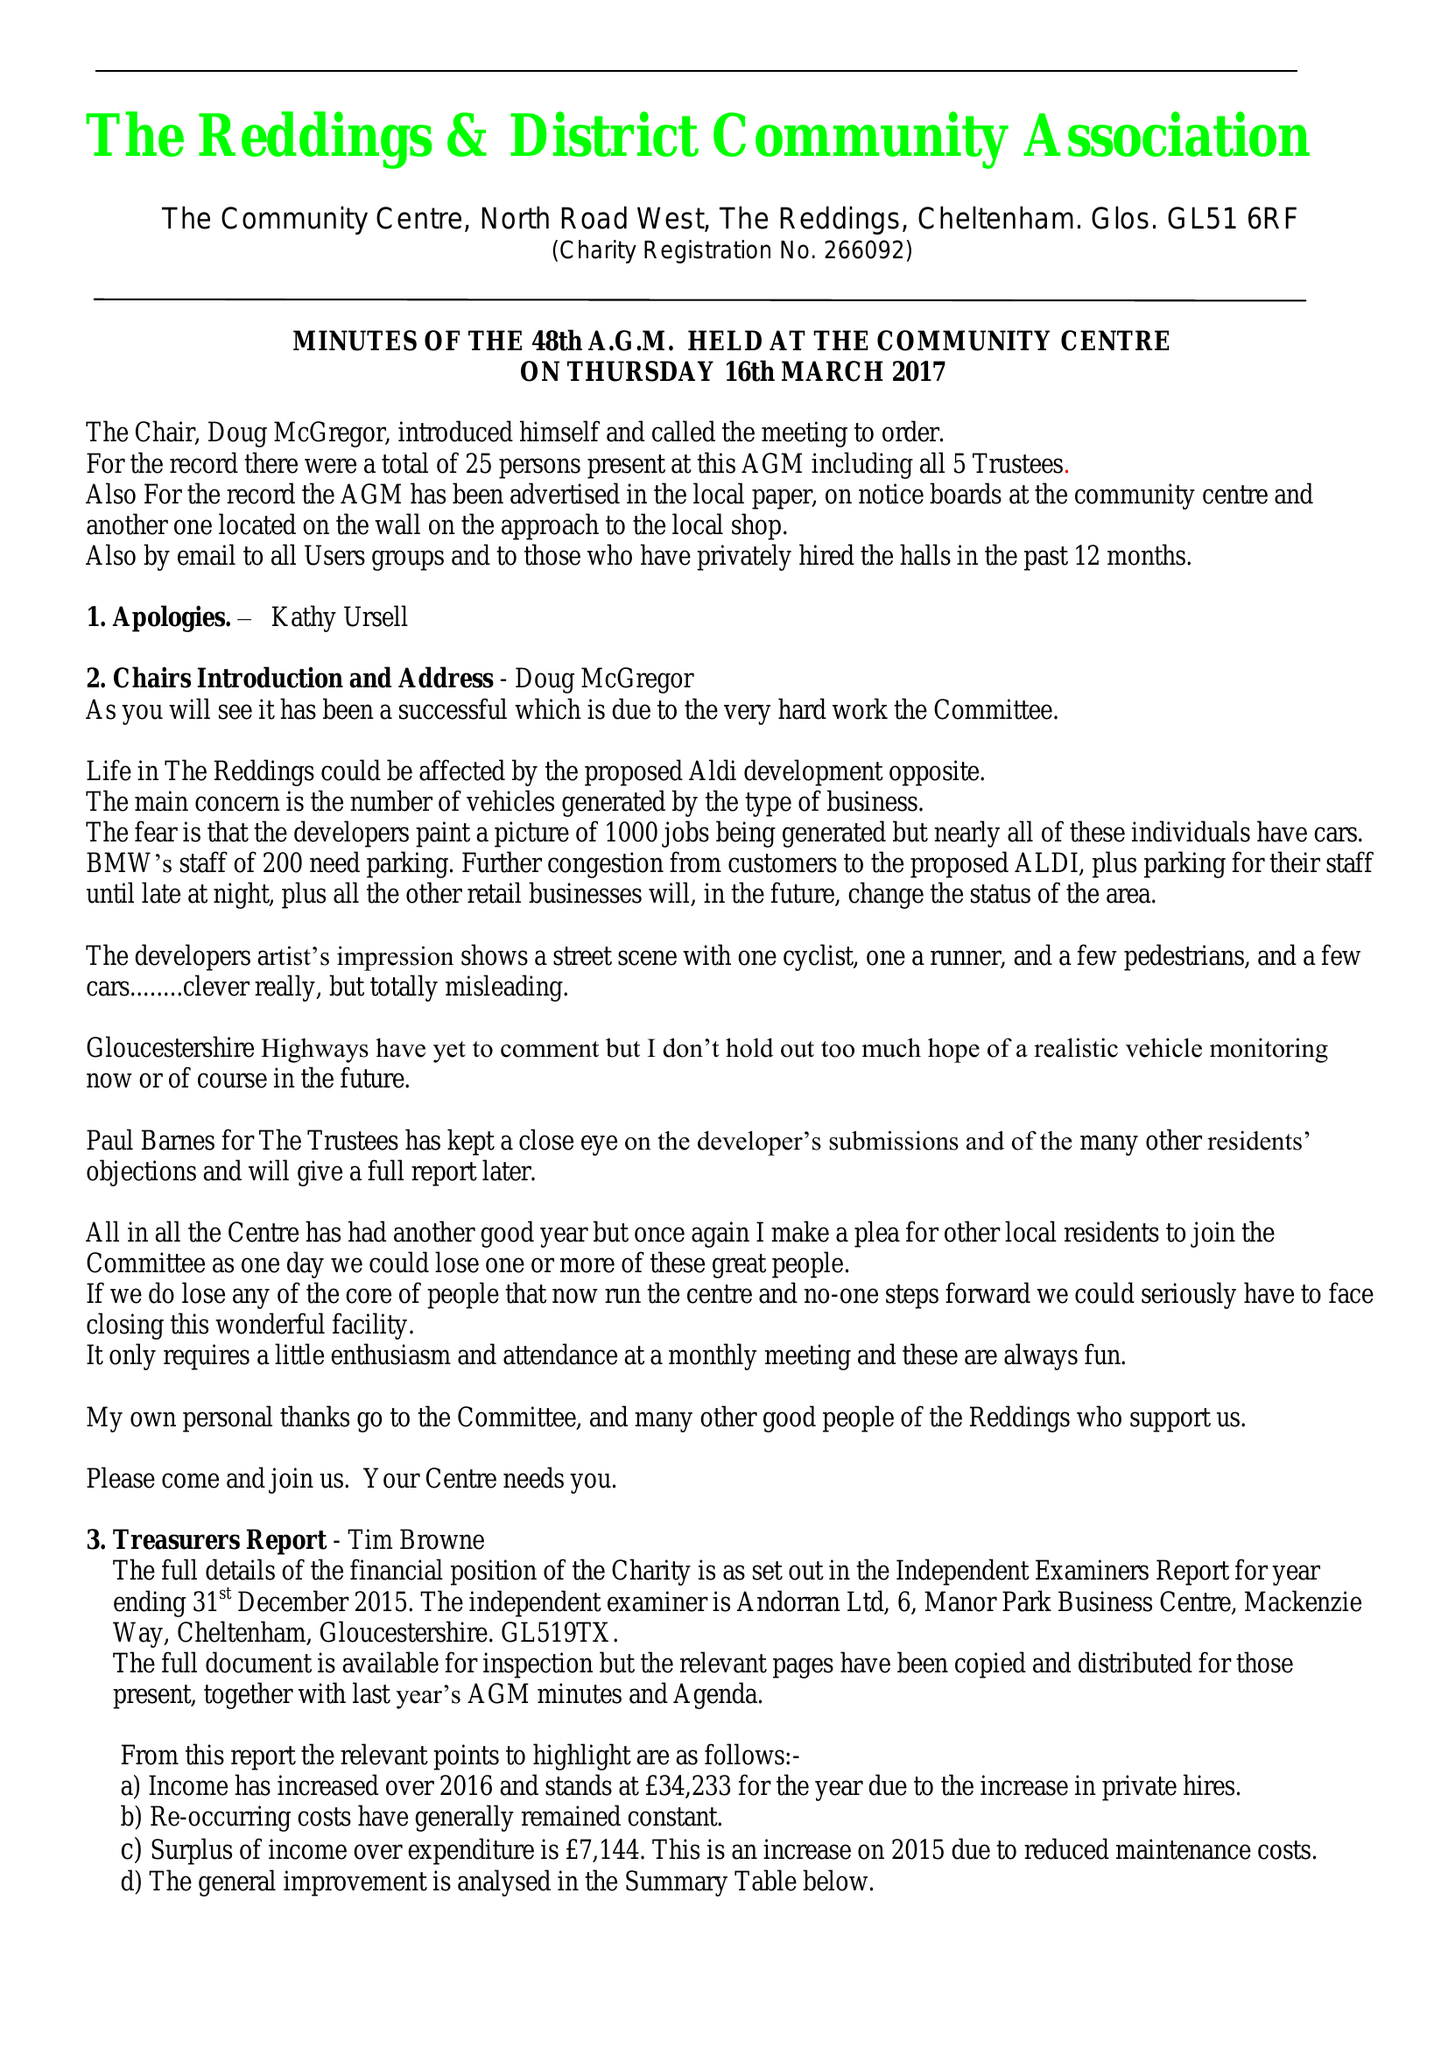What is the value for the address__street_line?
Answer the question using a single word or phrase. NORTH ROAD WEST 